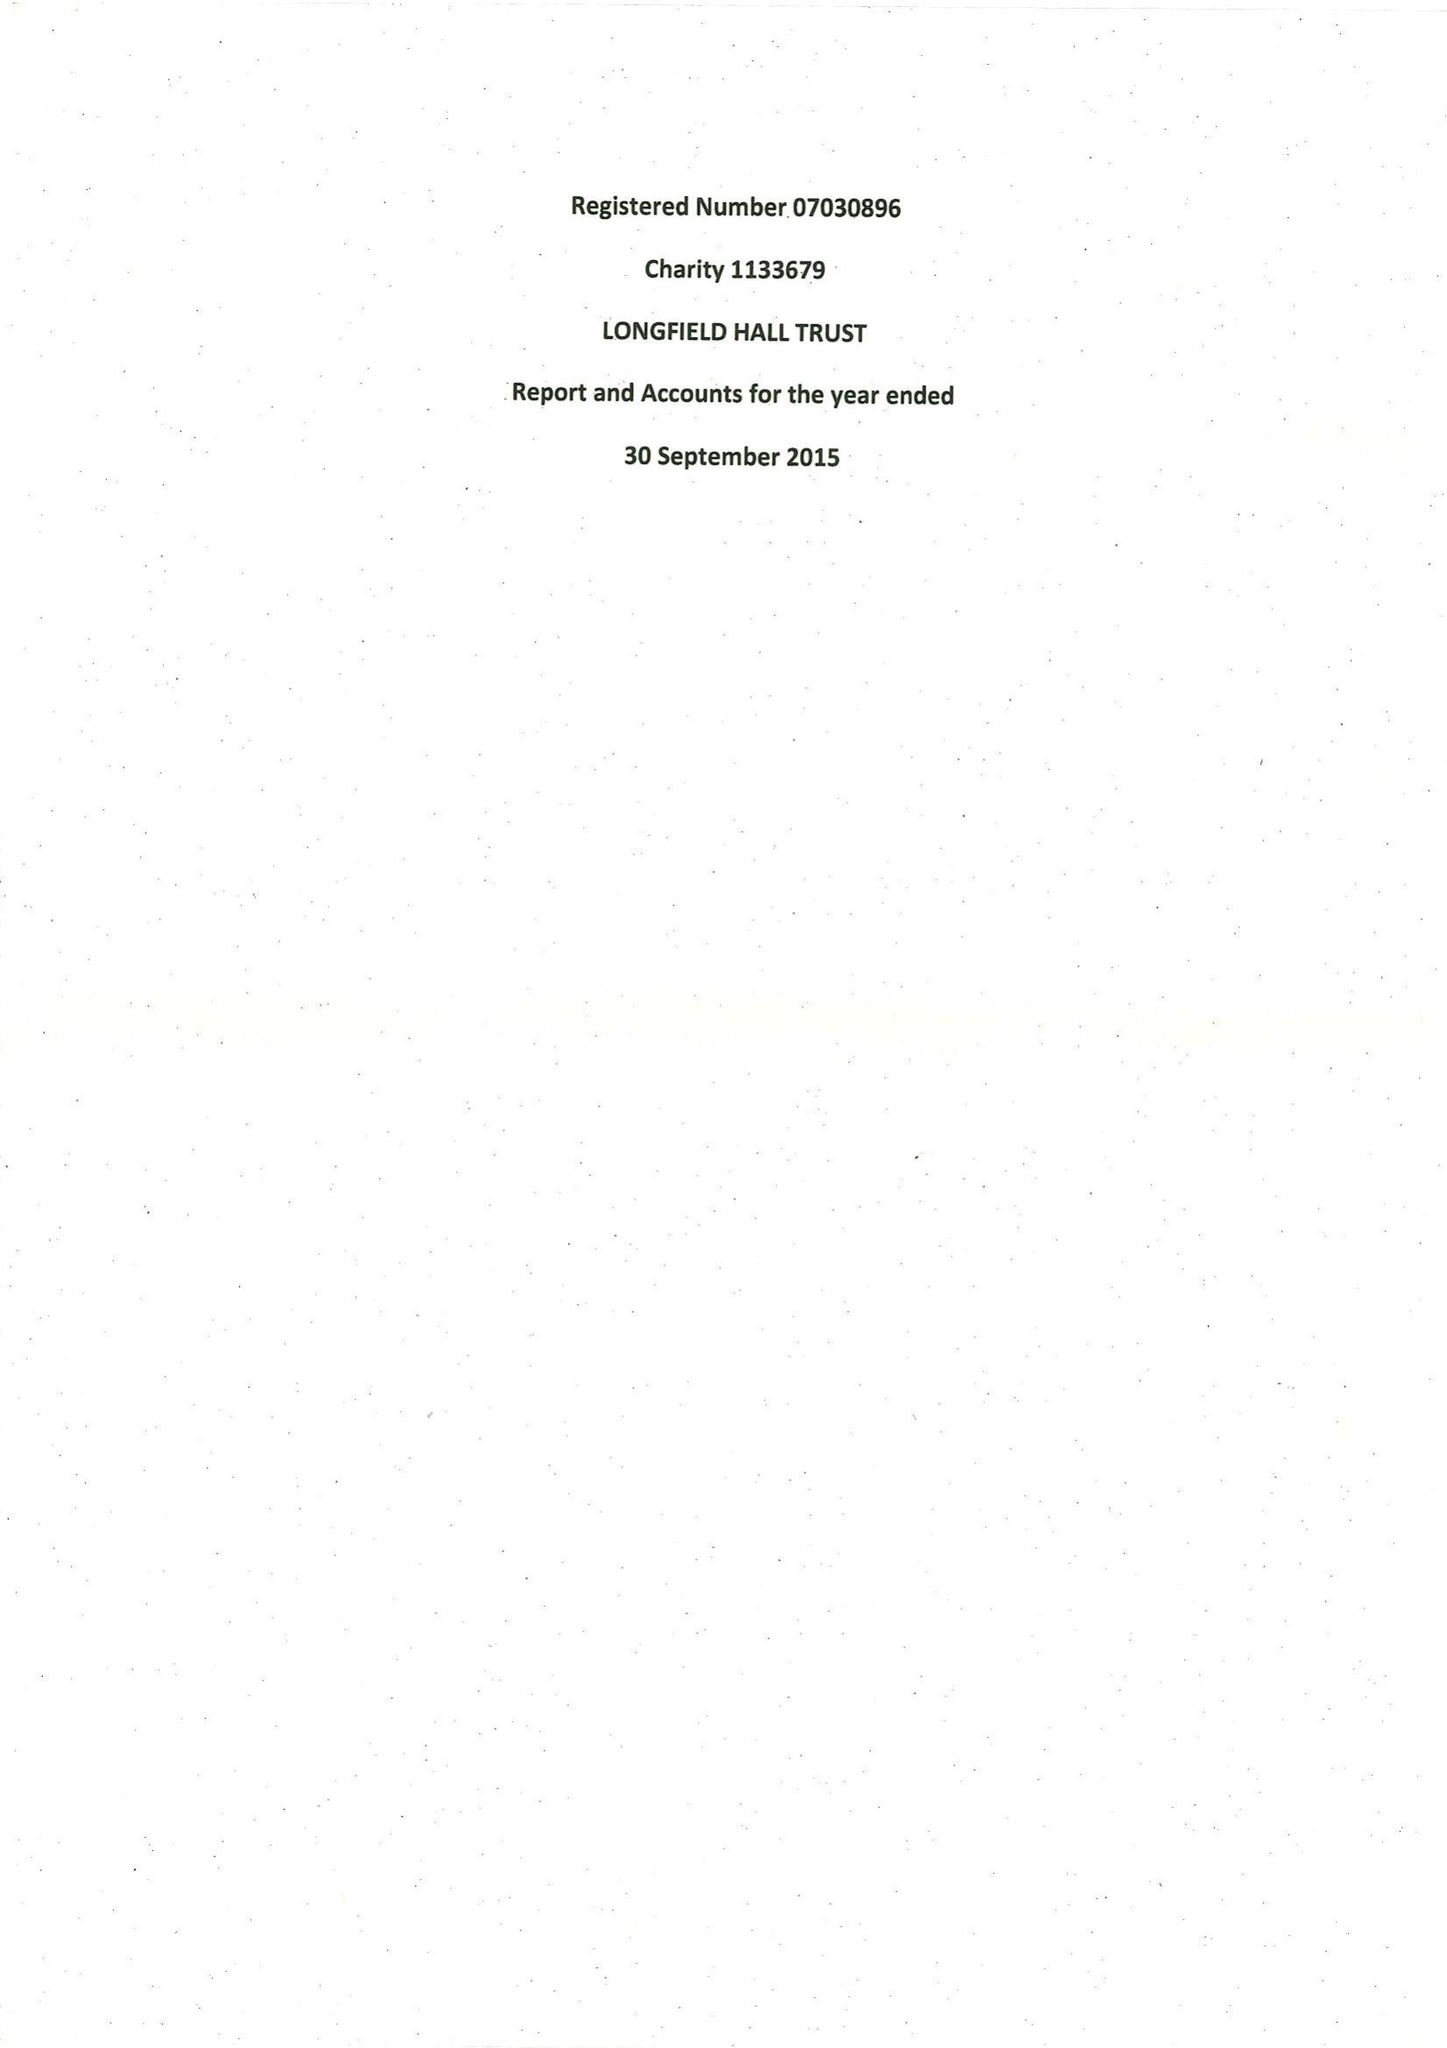What is the value for the income_annually_in_british_pounds?
Answer the question using a single word or phrase. 146686.00 